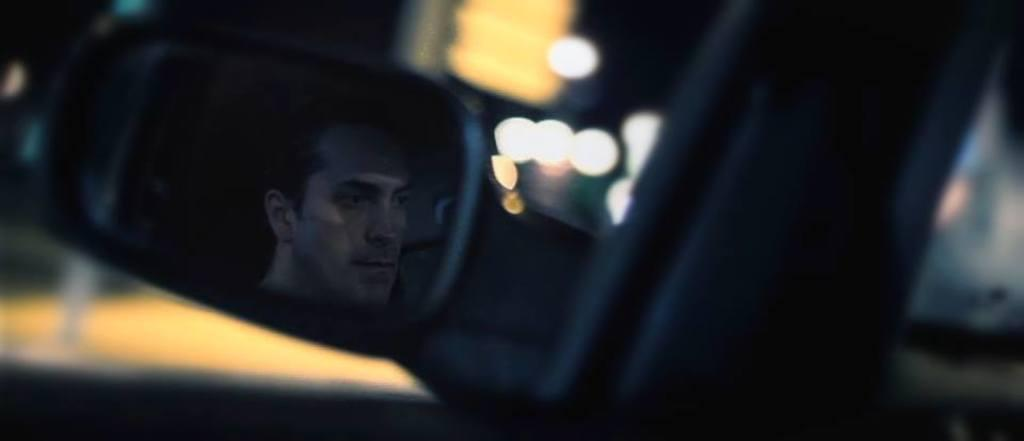Who is present in the image? There is a man in the image. How is the man depicted in the image? The man is reflected in a car side view mirror. What can be observed about the background in the image? The background in the image is blurred. What is the man's opinion on the cars in the image? There is no indication of the man's opinion on cars in the image, as it only shows his reflection in a car side view mirror. 